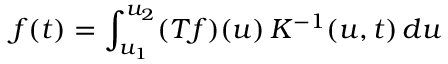<formula> <loc_0><loc_0><loc_500><loc_500>f ( t ) = \int _ { u _ { 1 } } ^ { u _ { 2 } } ( T f ) ( u ) \, K ^ { - 1 } ( u , t ) \, d u</formula> 